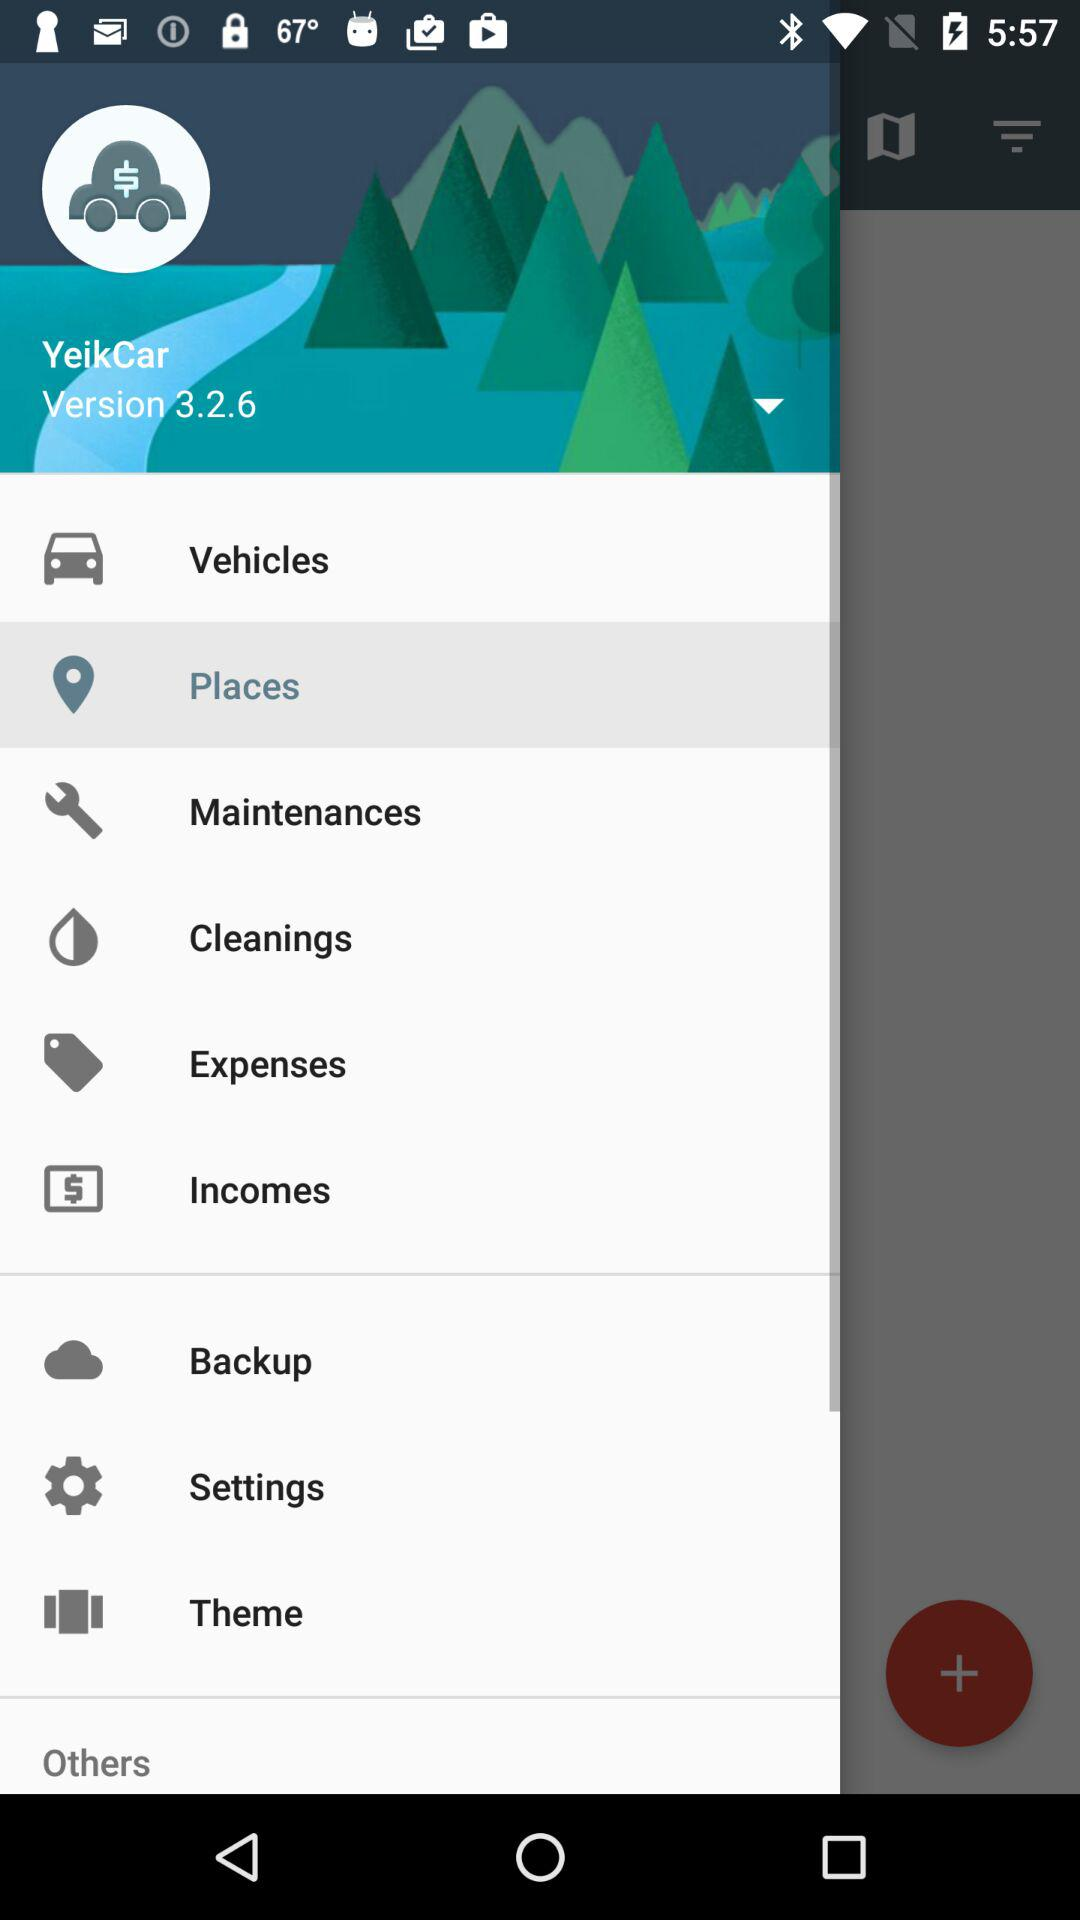What is the version of this app? The version is 3.2.6. 